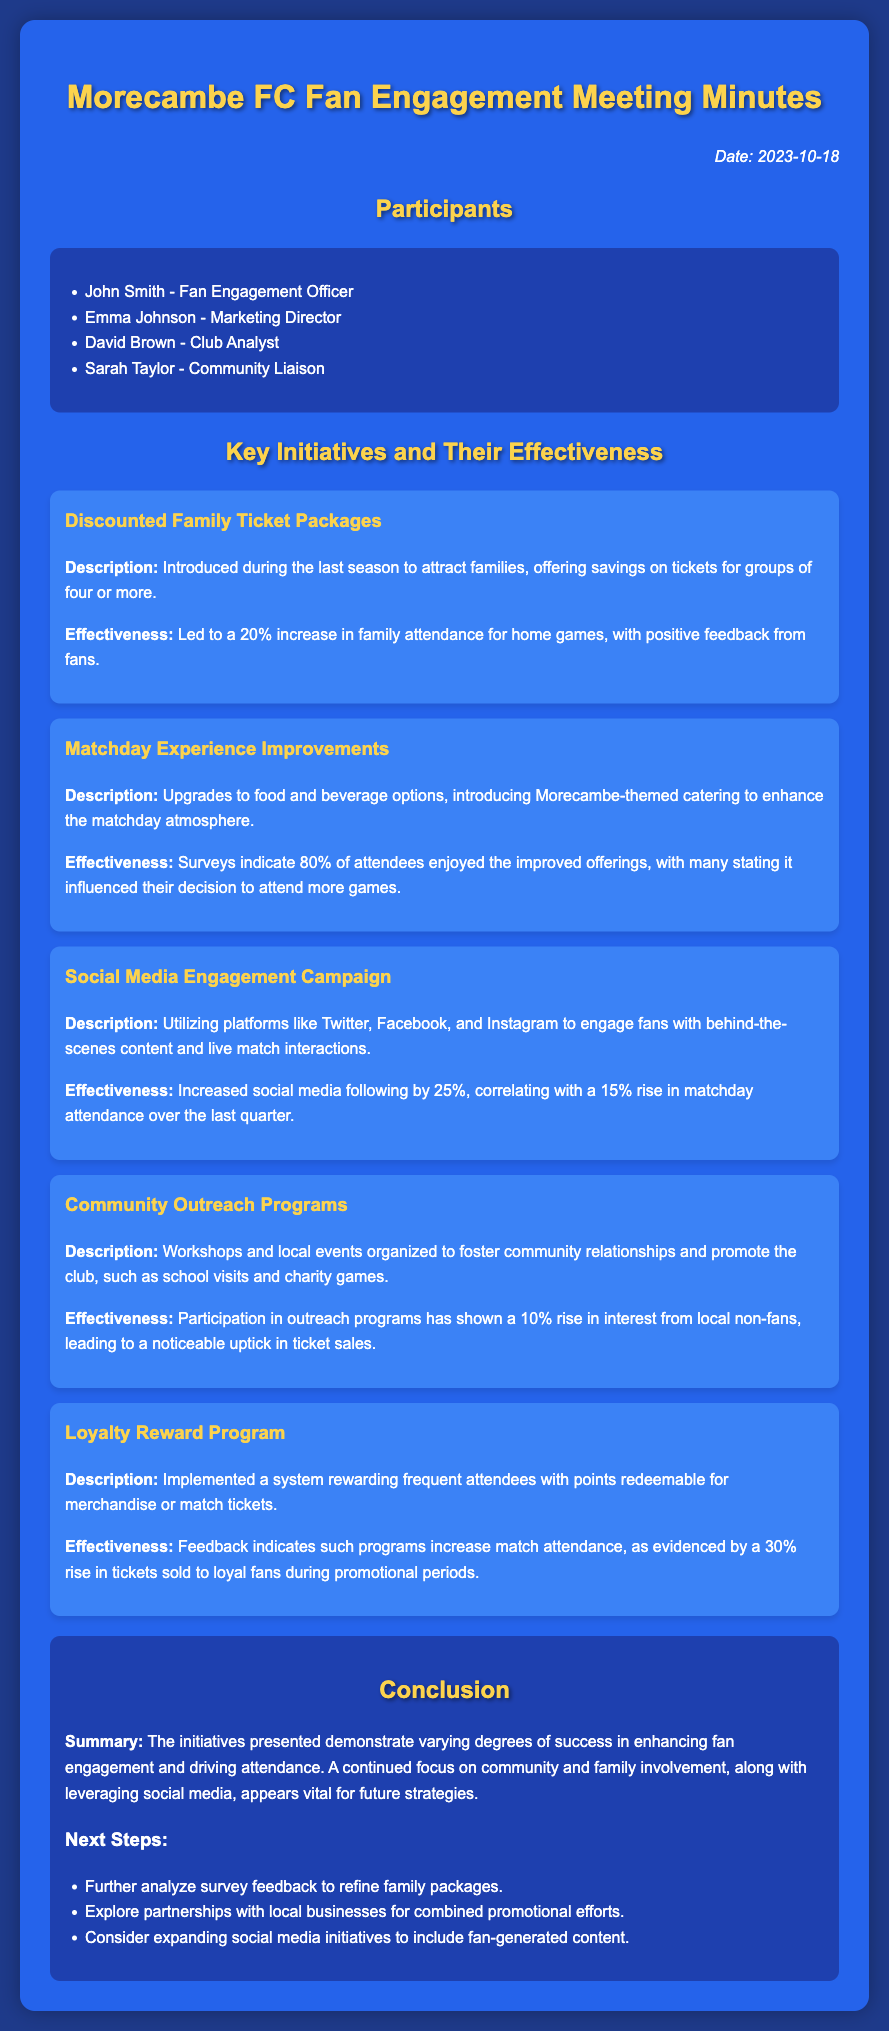What was the date of the meeting? The date of the meeting is stated at the top of the document.
Answer: 2023-10-18 Who is the Fan Engagement Officer? The document lists participants, including their roles and names.
Answer: John Smith What percentage increase in family attendance was recorded? The effectiveness section for the discounted family ticket packages specifies this increase.
Answer: 20% Which initiative had an 80% satisfaction rate among attendees? The matchday experience improvements mention this satisfaction rate in their effectiveness section.
Answer: Matchday Experience Improvements By how much did the social media following increase? The effectiveness of the social media engagement campaign provides this specific detail.
Answer: 25% What system rewards frequent attendees? The loyalty reward program description indicates this system.
Answer: Loyalty Reward Program Which type of outreach had a 10% rise in local interest? The community outreach programs effectiveness indicates this detail.
Answer: Community Outreach Programs What is the main conclusion drawn from the initiatives? The conclusion section summarizes the overall effectiveness of the initiatives.
Answer: Varying degrees of success What is one of the next steps mentioned for future strategies? The next steps listed in the conclusion provide various strategies for improvement.
Answer: Analyze survey feedback 